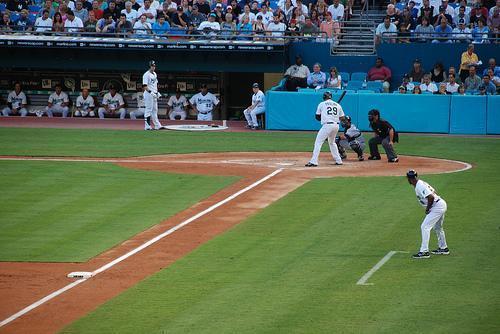How many bases in the picture?
Give a very brief answer. 2. 